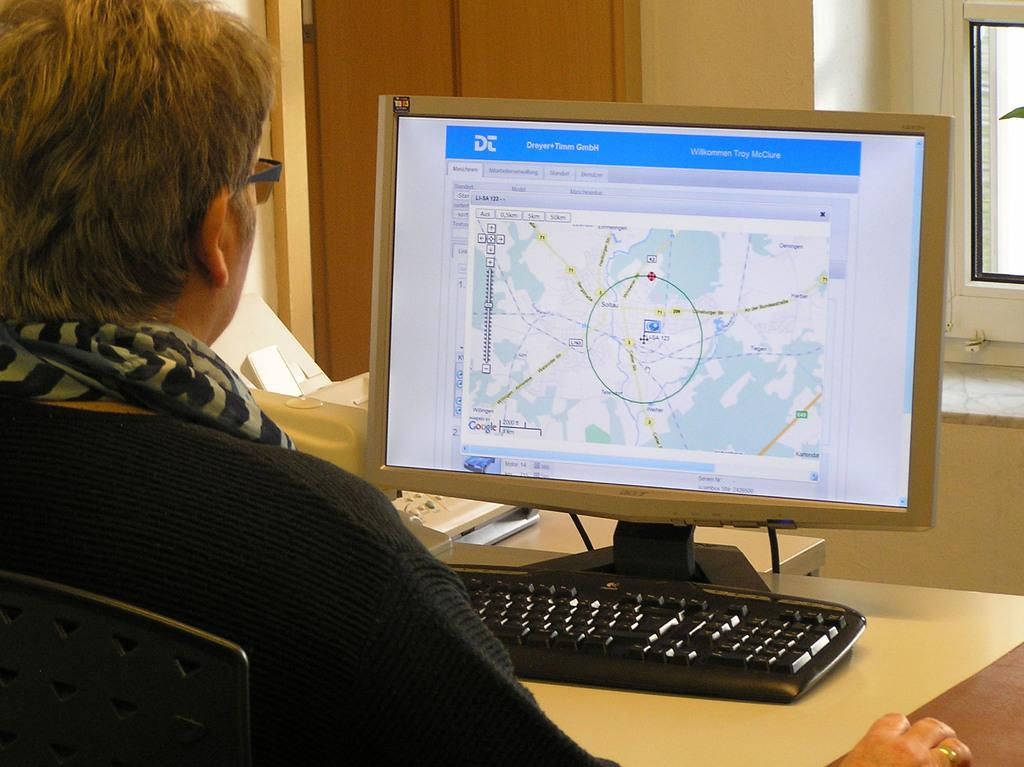What is the person in the image doing? The person is operating a computer. What feature does the computer have? The computer has windows. Can you describe any other objects or features in the image? There is a door in the image. What type of popcorn is being used to paste the ant on the computer screen in the image? There is no popcorn, paste, or ant present in the image. 